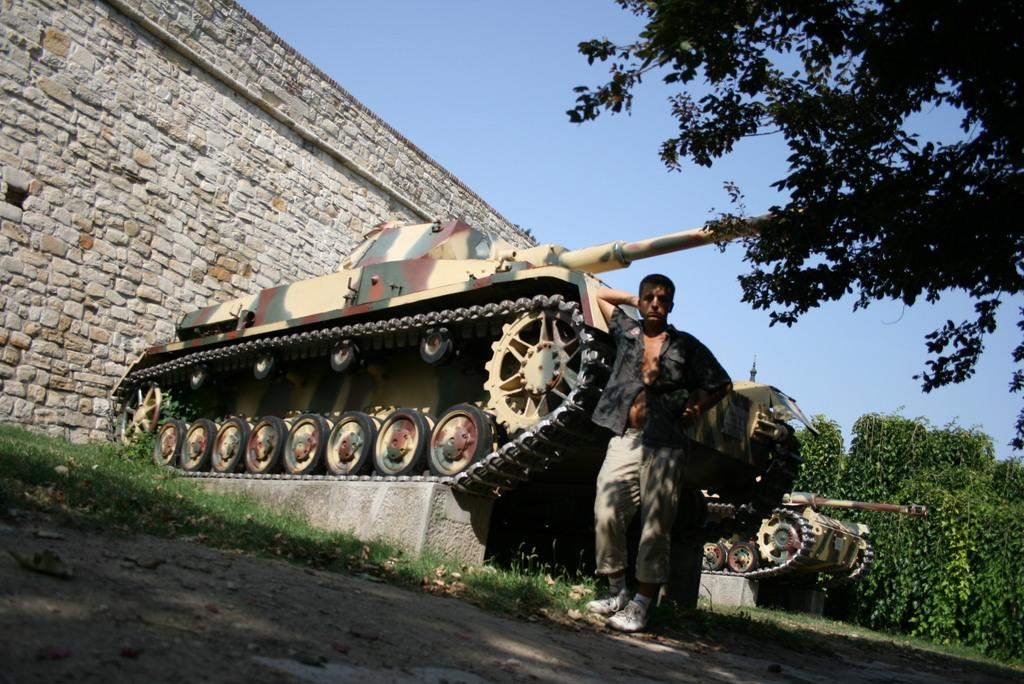What is the main subject of the image? There is a man standing in the image. What can be seen on the right side of the image? There are green color trees on the right side of the image. What is the color of the sky in the image? The sky is blue in color and visible at the top of the image. What type of floor can be seen in the image? There is no floor visible in the image, as it appears to be an outdoor scene with the man standing on the ground. 